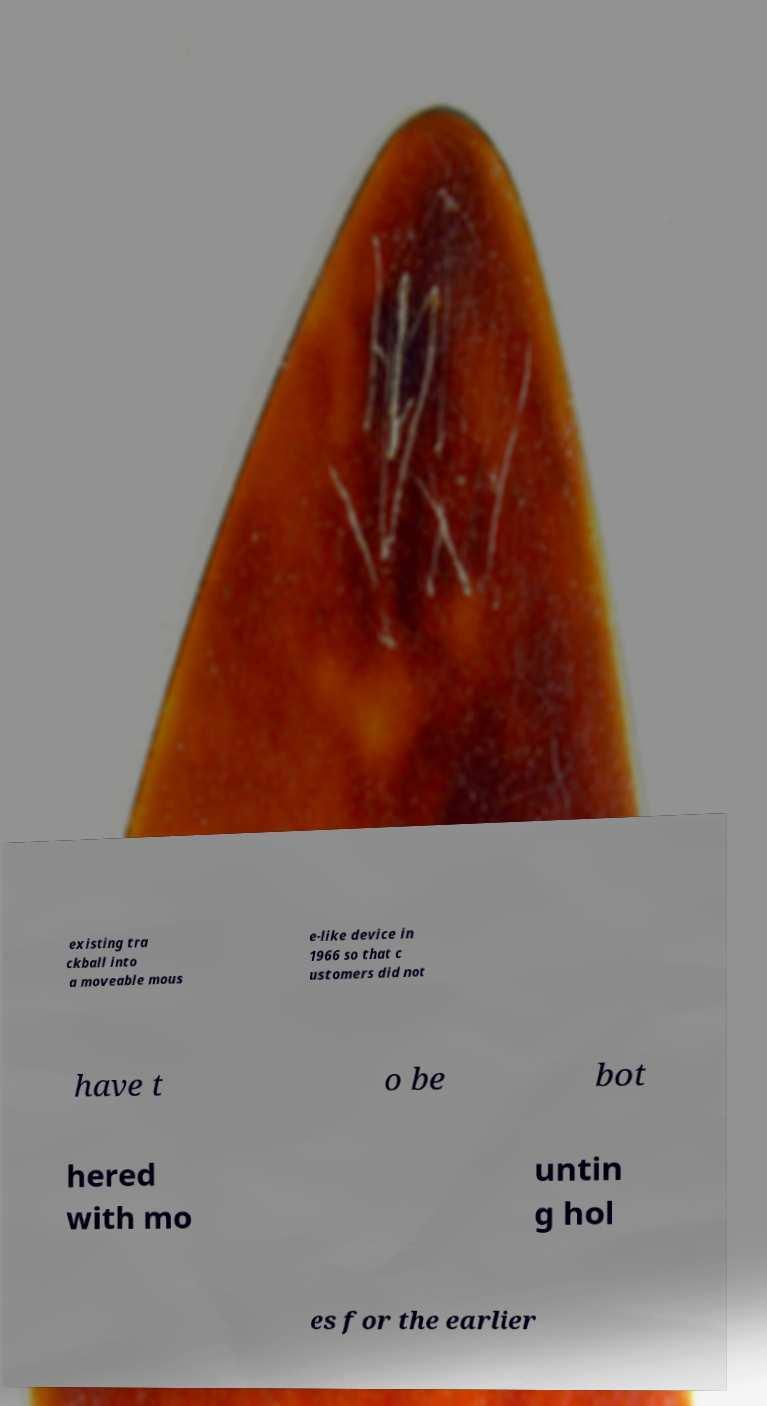I need the written content from this picture converted into text. Can you do that? existing tra ckball into a moveable mous e-like device in 1966 so that c ustomers did not have t o be bot hered with mo untin g hol es for the earlier 